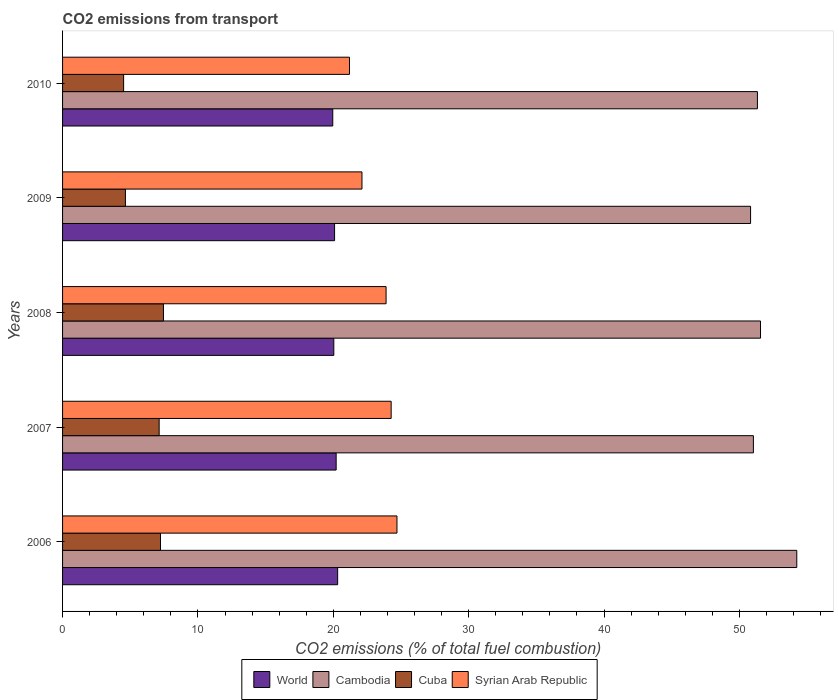How many different coloured bars are there?
Make the answer very short. 4. How many groups of bars are there?
Make the answer very short. 5. Are the number of bars on each tick of the Y-axis equal?
Give a very brief answer. Yes. What is the total CO2 emitted in Syrian Arab Republic in 2010?
Your response must be concise. 21.2. Across all years, what is the maximum total CO2 emitted in Cuba?
Ensure brevity in your answer.  7.45. Across all years, what is the minimum total CO2 emitted in Syrian Arab Republic?
Your answer should be compact. 21.2. In which year was the total CO2 emitted in World maximum?
Keep it short and to the point. 2006. In which year was the total CO2 emitted in Cambodia minimum?
Provide a succinct answer. 2009. What is the total total CO2 emitted in Cambodia in the graph?
Give a very brief answer. 258.98. What is the difference between the total CO2 emitted in Cambodia in 2008 and that in 2010?
Ensure brevity in your answer.  0.23. What is the difference between the total CO2 emitted in Cambodia in 2009 and the total CO2 emitted in Syrian Arab Republic in 2007?
Your answer should be very brief. 26.55. What is the average total CO2 emitted in Syrian Arab Republic per year?
Offer a very short reply. 23.24. In the year 2009, what is the difference between the total CO2 emitted in World and total CO2 emitted in Syrian Arab Republic?
Offer a terse response. -2.02. In how many years, is the total CO2 emitted in Cuba greater than 52 ?
Ensure brevity in your answer.  0. What is the ratio of the total CO2 emitted in Syrian Arab Republic in 2006 to that in 2008?
Make the answer very short. 1.03. What is the difference between the highest and the second highest total CO2 emitted in Cambodia?
Your answer should be very brief. 2.68. What is the difference between the highest and the lowest total CO2 emitted in World?
Keep it short and to the point. 0.36. Is the sum of the total CO2 emitted in Syrian Arab Republic in 2008 and 2010 greater than the maximum total CO2 emitted in World across all years?
Ensure brevity in your answer.  Yes. What does the 2nd bar from the top in 2007 represents?
Provide a short and direct response. Cuba. Is it the case that in every year, the sum of the total CO2 emitted in Cuba and total CO2 emitted in World is greater than the total CO2 emitted in Syrian Arab Republic?
Keep it short and to the point. Yes. How many bars are there?
Make the answer very short. 20. How many years are there in the graph?
Provide a succinct answer. 5. What is the difference between two consecutive major ticks on the X-axis?
Your answer should be very brief. 10. How many legend labels are there?
Make the answer very short. 4. What is the title of the graph?
Your response must be concise. CO2 emissions from transport. What is the label or title of the X-axis?
Give a very brief answer. CO2 emissions (% of total fuel combustion). What is the CO2 emissions (% of total fuel combustion) in World in 2006?
Keep it short and to the point. 20.32. What is the CO2 emissions (% of total fuel combustion) of Cambodia in 2006?
Keep it short and to the point. 54.24. What is the CO2 emissions (% of total fuel combustion) in Cuba in 2006?
Provide a short and direct response. 7.23. What is the CO2 emissions (% of total fuel combustion) of Syrian Arab Republic in 2006?
Your answer should be very brief. 24.7. What is the CO2 emissions (% of total fuel combustion) in World in 2007?
Ensure brevity in your answer.  20.21. What is the CO2 emissions (% of total fuel combustion) in Cambodia in 2007?
Your answer should be very brief. 51.03. What is the CO2 emissions (% of total fuel combustion) of Cuba in 2007?
Your answer should be very brief. 7.13. What is the CO2 emissions (% of total fuel combustion) of Syrian Arab Republic in 2007?
Provide a succinct answer. 24.27. What is the CO2 emissions (% of total fuel combustion) of World in 2008?
Provide a short and direct response. 20.04. What is the CO2 emissions (% of total fuel combustion) of Cambodia in 2008?
Provide a succinct answer. 51.56. What is the CO2 emissions (% of total fuel combustion) in Cuba in 2008?
Your response must be concise. 7.45. What is the CO2 emissions (% of total fuel combustion) of Syrian Arab Republic in 2008?
Your answer should be compact. 23.9. What is the CO2 emissions (% of total fuel combustion) in World in 2009?
Provide a succinct answer. 20.09. What is the CO2 emissions (% of total fuel combustion) in Cambodia in 2009?
Your response must be concise. 50.82. What is the CO2 emissions (% of total fuel combustion) of Cuba in 2009?
Your answer should be very brief. 4.64. What is the CO2 emissions (% of total fuel combustion) of Syrian Arab Republic in 2009?
Your response must be concise. 22.12. What is the CO2 emissions (% of total fuel combustion) in World in 2010?
Give a very brief answer. 19.96. What is the CO2 emissions (% of total fuel combustion) of Cambodia in 2010?
Offer a very short reply. 51.33. What is the CO2 emissions (% of total fuel combustion) in Cuba in 2010?
Your answer should be very brief. 4.51. What is the CO2 emissions (% of total fuel combustion) of Syrian Arab Republic in 2010?
Offer a very short reply. 21.2. Across all years, what is the maximum CO2 emissions (% of total fuel combustion) of World?
Your answer should be very brief. 20.32. Across all years, what is the maximum CO2 emissions (% of total fuel combustion) of Cambodia?
Provide a succinct answer. 54.24. Across all years, what is the maximum CO2 emissions (% of total fuel combustion) of Cuba?
Offer a very short reply. 7.45. Across all years, what is the maximum CO2 emissions (% of total fuel combustion) of Syrian Arab Republic?
Ensure brevity in your answer.  24.7. Across all years, what is the minimum CO2 emissions (% of total fuel combustion) in World?
Make the answer very short. 19.96. Across all years, what is the minimum CO2 emissions (% of total fuel combustion) of Cambodia?
Ensure brevity in your answer.  50.82. Across all years, what is the minimum CO2 emissions (% of total fuel combustion) of Cuba?
Offer a very short reply. 4.51. Across all years, what is the minimum CO2 emissions (% of total fuel combustion) in Syrian Arab Republic?
Offer a very short reply. 21.2. What is the total CO2 emissions (% of total fuel combustion) in World in the graph?
Give a very brief answer. 100.62. What is the total CO2 emissions (% of total fuel combustion) in Cambodia in the graph?
Your response must be concise. 258.98. What is the total CO2 emissions (% of total fuel combustion) in Cuba in the graph?
Offer a terse response. 30.98. What is the total CO2 emissions (% of total fuel combustion) in Syrian Arab Republic in the graph?
Offer a very short reply. 116.19. What is the difference between the CO2 emissions (% of total fuel combustion) of World in 2006 and that in 2007?
Your response must be concise. 0.11. What is the difference between the CO2 emissions (% of total fuel combustion) in Cambodia in 2006 and that in 2007?
Make the answer very short. 3.2. What is the difference between the CO2 emissions (% of total fuel combustion) in Cuba in 2006 and that in 2007?
Provide a succinct answer. 0.1. What is the difference between the CO2 emissions (% of total fuel combustion) of Syrian Arab Republic in 2006 and that in 2007?
Keep it short and to the point. 0.43. What is the difference between the CO2 emissions (% of total fuel combustion) of World in 2006 and that in 2008?
Your answer should be very brief. 0.28. What is the difference between the CO2 emissions (% of total fuel combustion) of Cambodia in 2006 and that in 2008?
Your response must be concise. 2.68. What is the difference between the CO2 emissions (% of total fuel combustion) in Cuba in 2006 and that in 2008?
Provide a short and direct response. -0.22. What is the difference between the CO2 emissions (% of total fuel combustion) of Syrian Arab Republic in 2006 and that in 2008?
Ensure brevity in your answer.  0.8. What is the difference between the CO2 emissions (% of total fuel combustion) of World in 2006 and that in 2009?
Your answer should be very brief. 0.23. What is the difference between the CO2 emissions (% of total fuel combustion) of Cambodia in 2006 and that in 2009?
Give a very brief answer. 3.41. What is the difference between the CO2 emissions (% of total fuel combustion) of Cuba in 2006 and that in 2009?
Keep it short and to the point. 2.59. What is the difference between the CO2 emissions (% of total fuel combustion) of Syrian Arab Republic in 2006 and that in 2009?
Make the answer very short. 2.58. What is the difference between the CO2 emissions (% of total fuel combustion) of World in 2006 and that in 2010?
Provide a succinct answer. 0.36. What is the difference between the CO2 emissions (% of total fuel combustion) of Cambodia in 2006 and that in 2010?
Ensure brevity in your answer.  2.91. What is the difference between the CO2 emissions (% of total fuel combustion) in Cuba in 2006 and that in 2010?
Keep it short and to the point. 2.72. What is the difference between the CO2 emissions (% of total fuel combustion) in Syrian Arab Republic in 2006 and that in 2010?
Offer a very short reply. 3.51. What is the difference between the CO2 emissions (% of total fuel combustion) in World in 2007 and that in 2008?
Your answer should be compact. 0.17. What is the difference between the CO2 emissions (% of total fuel combustion) in Cambodia in 2007 and that in 2008?
Provide a short and direct response. -0.53. What is the difference between the CO2 emissions (% of total fuel combustion) in Cuba in 2007 and that in 2008?
Offer a terse response. -0.32. What is the difference between the CO2 emissions (% of total fuel combustion) of Syrian Arab Republic in 2007 and that in 2008?
Provide a succinct answer. 0.38. What is the difference between the CO2 emissions (% of total fuel combustion) in World in 2007 and that in 2009?
Provide a succinct answer. 0.12. What is the difference between the CO2 emissions (% of total fuel combustion) of Cambodia in 2007 and that in 2009?
Offer a terse response. 0.21. What is the difference between the CO2 emissions (% of total fuel combustion) of Cuba in 2007 and that in 2009?
Offer a very short reply. 2.49. What is the difference between the CO2 emissions (% of total fuel combustion) of Syrian Arab Republic in 2007 and that in 2009?
Provide a succinct answer. 2.16. What is the difference between the CO2 emissions (% of total fuel combustion) in World in 2007 and that in 2010?
Offer a very short reply. 0.25. What is the difference between the CO2 emissions (% of total fuel combustion) in Cambodia in 2007 and that in 2010?
Your response must be concise. -0.3. What is the difference between the CO2 emissions (% of total fuel combustion) in Cuba in 2007 and that in 2010?
Make the answer very short. 2.62. What is the difference between the CO2 emissions (% of total fuel combustion) in Syrian Arab Republic in 2007 and that in 2010?
Ensure brevity in your answer.  3.08. What is the difference between the CO2 emissions (% of total fuel combustion) in World in 2008 and that in 2009?
Keep it short and to the point. -0.06. What is the difference between the CO2 emissions (% of total fuel combustion) of Cambodia in 2008 and that in 2009?
Give a very brief answer. 0.73. What is the difference between the CO2 emissions (% of total fuel combustion) of Cuba in 2008 and that in 2009?
Keep it short and to the point. 2.81. What is the difference between the CO2 emissions (% of total fuel combustion) in Syrian Arab Republic in 2008 and that in 2009?
Your response must be concise. 1.78. What is the difference between the CO2 emissions (% of total fuel combustion) of World in 2008 and that in 2010?
Make the answer very short. 0.08. What is the difference between the CO2 emissions (% of total fuel combustion) in Cambodia in 2008 and that in 2010?
Your answer should be compact. 0.23. What is the difference between the CO2 emissions (% of total fuel combustion) in Cuba in 2008 and that in 2010?
Provide a succinct answer. 2.94. What is the difference between the CO2 emissions (% of total fuel combustion) of Syrian Arab Republic in 2008 and that in 2010?
Offer a terse response. 2.7. What is the difference between the CO2 emissions (% of total fuel combustion) of World in 2009 and that in 2010?
Offer a terse response. 0.13. What is the difference between the CO2 emissions (% of total fuel combustion) of Cambodia in 2009 and that in 2010?
Your answer should be very brief. -0.51. What is the difference between the CO2 emissions (% of total fuel combustion) in Cuba in 2009 and that in 2010?
Provide a succinct answer. 0.13. What is the difference between the CO2 emissions (% of total fuel combustion) in Syrian Arab Republic in 2009 and that in 2010?
Offer a very short reply. 0.92. What is the difference between the CO2 emissions (% of total fuel combustion) of World in 2006 and the CO2 emissions (% of total fuel combustion) of Cambodia in 2007?
Keep it short and to the point. -30.71. What is the difference between the CO2 emissions (% of total fuel combustion) in World in 2006 and the CO2 emissions (% of total fuel combustion) in Cuba in 2007?
Offer a very short reply. 13.19. What is the difference between the CO2 emissions (% of total fuel combustion) of World in 2006 and the CO2 emissions (% of total fuel combustion) of Syrian Arab Republic in 2007?
Your answer should be very brief. -3.95. What is the difference between the CO2 emissions (% of total fuel combustion) of Cambodia in 2006 and the CO2 emissions (% of total fuel combustion) of Cuba in 2007?
Provide a succinct answer. 47.1. What is the difference between the CO2 emissions (% of total fuel combustion) in Cambodia in 2006 and the CO2 emissions (% of total fuel combustion) in Syrian Arab Republic in 2007?
Provide a succinct answer. 29.96. What is the difference between the CO2 emissions (% of total fuel combustion) in Cuba in 2006 and the CO2 emissions (% of total fuel combustion) in Syrian Arab Republic in 2007?
Your response must be concise. -17.04. What is the difference between the CO2 emissions (% of total fuel combustion) in World in 2006 and the CO2 emissions (% of total fuel combustion) in Cambodia in 2008?
Keep it short and to the point. -31.24. What is the difference between the CO2 emissions (% of total fuel combustion) in World in 2006 and the CO2 emissions (% of total fuel combustion) in Cuba in 2008?
Ensure brevity in your answer.  12.87. What is the difference between the CO2 emissions (% of total fuel combustion) in World in 2006 and the CO2 emissions (% of total fuel combustion) in Syrian Arab Republic in 2008?
Provide a succinct answer. -3.58. What is the difference between the CO2 emissions (% of total fuel combustion) in Cambodia in 2006 and the CO2 emissions (% of total fuel combustion) in Cuba in 2008?
Your answer should be compact. 46.78. What is the difference between the CO2 emissions (% of total fuel combustion) of Cambodia in 2006 and the CO2 emissions (% of total fuel combustion) of Syrian Arab Republic in 2008?
Ensure brevity in your answer.  30.34. What is the difference between the CO2 emissions (% of total fuel combustion) of Cuba in 2006 and the CO2 emissions (% of total fuel combustion) of Syrian Arab Republic in 2008?
Make the answer very short. -16.66. What is the difference between the CO2 emissions (% of total fuel combustion) in World in 2006 and the CO2 emissions (% of total fuel combustion) in Cambodia in 2009?
Give a very brief answer. -30.5. What is the difference between the CO2 emissions (% of total fuel combustion) in World in 2006 and the CO2 emissions (% of total fuel combustion) in Cuba in 2009?
Provide a short and direct response. 15.68. What is the difference between the CO2 emissions (% of total fuel combustion) of World in 2006 and the CO2 emissions (% of total fuel combustion) of Syrian Arab Republic in 2009?
Offer a very short reply. -1.8. What is the difference between the CO2 emissions (% of total fuel combustion) of Cambodia in 2006 and the CO2 emissions (% of total fuel combustion) of Cuba in 2009?
Provide a short and direct response. 49.59. What is the difference between the CO2 emissions (% of total fuel combustion) in Cambodia in 2006 and the CO2 emissions (% of total fuel combustion) in Syrian Arab Republic in 2009?
Keep it short and to the point. 32.12. What is the difference between the CO2 emissions (% of total fuel combustion) of Cuba in 2006 and the CO2 emissions (% of total fuel combustion) of Syrian Arab Republic in 2009?
Your answer should be compact. -14.88. What is the difference between the CO2 emissions (% of total fuel combustion) of World in 2006 and the CO2 emissions (% of total fuel combustion) of Cambodia in 2010?
Offer a terse response. -31.01. What is the difference between the CO2 emissions (% of total fuel combustion) in World in 2006 and the CO2 emissions (% of total fuel combustion) in Cuba in 2010?
Your response must be concise. 15.81. What is the difference between the CO2 emissions (% of total fuel combustion) in World in 2006 and the CO2 emissions (% of total fuel combustion) in Syrian Arab Republic in 2010?
Offer a very short reply. -0.88. What is the difference between the CO2 emissions (% of total fuel combustion) in Cambodia in 2006 and the CO2 emissions (% of total fuel combustion) in Cuba in 2010?
Provide a succinct answer. 49.73. What is the difference between the CO2 emissions (% of total fuel combustion) of Cambodia in 2006 and the CO2 emissions (% of total fuel combustion) of Syrian Arab Republic in 2010?
Make the answer very short. 33.04. What is the difference between the CO2 emissions (% of total fuel combustion) of Cuba in 2006 and the CO2 emissions (% of total fuel combustion) of Syrian Arab Republic in 2010?
Make the answer very short. -13.96. What is the difference between the CO2 emissions (% of total fuel combustion) in World in 2007 and the CO2 emissions (% of total fuel combustion) in Cambodia in 2008?
Ensure brevity in your answer.  -31.35. What is the difference between the CO2 emissions (% of total fuel combustion) in World in 2007 and the CO2 emissions (% of total fuel combustion) in Cuba in 2008?
Your answer should be compact. 12.76. What is the difference between the CO2 emissions (% of total fuel combustion) in World in 2007 and the CO2 emissions (% of total fuel combustion) in Syrian Arab Republic in 2008?
Your answer should be very brief. -3.69. What is the difference between the CO2 emissions (% of total fuel combustion) in Cambodia in 2007 and the CO2 emissions (% of total fuel combustion) in Cuba in 2008?
Keep it short and to the point. 43.58. What is the difference between the CO2 emissions (% of total fuel combustion) in Cambodia in 2007 and the CO2 emissions (% of total fuel combustion) in Syrian Arab Republic in 2008?
Offer a very short reply. 27.13. What is the difference between the CO2 emissions (% of total fuel combustion) of Cuba in 2007 and the CO2 emissions (% of total fuel combustion) of Syrian Arab Republic in 2008?
Your response must be concise. -16.76. What is the difference between the CO2 emissions (% of total fuel combustion) of World in 2007 and the CO2 emissions (% of total fuel combustion) of Cambodia in 2009?
Your answer should be compact. -30.61. What is the difference between the CO2 emissions (% of total fuel combustion) of World in 2007 and the CO2 emissions (% of total fuel combustion) of Cuba in 2009?
Your response must be concise. 15.57. What is the difference between the CO2 emissions (% of total fuel combustion) of World in 2007 and the CO2 emissions (% of total fuel combustion) of Syrian Arab Republic in 2009?
Keep it short and to the point. -1.91. What is the difference between the CO2 emissions (% of total fuel combustion) of Cambodia in 2007 and the CO2 emissions (% of total fuel combustion) of Cuba in 2009?
Give a very brief answer. 46.39. What is the difference between the CO2 emissions (% of total fuel combustion) in Cambodia in 2007 and the CO2 emissions (% of total fuel combustion) in Syrian Arab Republic in 2009?
Make the answer very short. 28.91. What is the difference between the CO2 emissions (% of total fuel combustion) in Cuba in 2007 and the CO2 emissions (% of total fuel combustion) in Syrian Arab Republic in 2009?
Keep it short and to the point. -14.98. What is the difference between the CO2 emissions (% of total fuel combustion) in World in 2007 and the CO2 emissions (% of total fuel combustion) in Cambodia in 2010?
Offer a terse response. -31.12. What is the difference between the CO2 emissions (% of total fuel combustion) of World in 2007 and the CO2 emissions (% of total fuel combustion) of Cuba in 2010?
Provide a succinct answer. 15.7. What is the difference between the CO2 emissions (% of total fuel combustion) in World in 2007 and the CO2 emissions (% of total fuel combustion) in Syrian Arab Republic in 2010?
Keep it short and to the point. -0.99. What is the difference between the CO2 emissions (% of total fuel combustion) of Cambodia in 2007 and the CO2 emissions (% of total fuel combustion) of Cuba in 2010?
Your answer should be very brief. 46.52. What is the difference between the CO2 emissions (% of total fuel combustion) of Cambodia in 2007 and the CO2 emissions (% of total fuel combustion) of Syrian Arab Republic in 2010?
Your response must be concise. 29.84. What is the difference between the CO2 emissions (% of total fuel combustion) of Cuba in 2007 and the CO2 emissions (% of total fuel combustion) of Syrian Arab Republic in 2010?
Give a very brief answer. -14.06. What is the difference between the CO2 emissions (% of total fuel combustion) in World in 2008 and the CO2 emissions (% of total fuel combustion) in Cambodia in 2009?
Provide a short and direct response. -30.79. What is the difference between the CO2 emissions (% of total fuel combustion) in World in 2008 and the CO2 emissions (% of total fuel combustion) in Cuba in 2009?
Offer a very short reply. 15.39. What is the difference between the CO2 emissions (% of total fuel combustion) in World in 2008 and the CO2 emissions (% of total fuel combustion) in Syrian Arab Republic in 2009?
Make the answer very short. -2.08. What is the difference between the CO2 emissions (% of total fuel combustion) in Cambodia in 2008 and the CO2 emissions (% of total fuel combustion) in Cuba in 2009?
Keep it short and to the point. 46.91. What is the difference between the CO2 emissions (% of total fuel combustion) of Cambodia in 2008 and the CO2 emissions (% of total fuel combustion) of Syrian Arab Republic in 2009?
Keep it short and to the point. 29.44. What is the difference between the CO2 emissions (% of total fuel combustion) in Cuba in 2008 and the CO2 emissions (% of total fuel combustion) in Syrian Arab Republic in 2009?
Provide a short and direct response. -14.66. What is the difference between the CO2 emissions (% of total fuel combustion) in World in 2008 and the CO2 emissions (% of total fuel combustion) in Cambodia in 2010?
Your answer should be compact. -31.29. What is the difference between the CO2 emissions (% of total fuel combustion) of World in 2008 and the CO2 emissions (% of total fuel combustion) of Cuba in 2010?
Ensure brevity in your answer.  15.53. What is the difference between the CO2 emissions (% of total fuel combustion) of World in 2008 and the CO2 emissions (% of total fuel combustion) of Syrian Arab Republic in 2010?
Offer a very short reply. -1.16. What is the difference between the CO2 emissions (% of total fuel combustion) in Cambodia in 2008 and the CO2 emissions (% of total fuel combustion) in Cuba in 2010?
Your answer should be very brief. 47.05. What is the difference between the CO2 emissions (% of total fuel combustion) of Cambodia in 2008 and the CO2 emissions (% of total fuel combustion) of Syrian Arab Republic in 2010?
Your answer should be very brief. 30.36. What is the difference between the CO2 emissions (% of total fuel combustion) of Cuba in 2008 and the CO2 emissions (% of total fuel combustion) of Syrian Arab Republic in 2010?
Provide a succinct answer. -13.74. What is the difference between the CO2 emissions (% of total fuel combustion) in World in 2009 and the CO2 emissions (% of total fuel combustion) in Cambodia in 2010?
Provide a succinct answer. -31.24. What is the difference between the CO2 emissions (% of total fuel combustion) in World in 2009 and the CO2 emissions (% of total fuel combustion) in Cuba in 2010?
Provide a short and direct response. 15.58. What is the difference between the CO2 emissions (% of total fuel combustion) in World in 2009 and the CO2 emissions (% of total fuel combustion) in Syrian Arab Republic in 2010?
Ensure brevity in your answer.  -1.1. What is the difference between the CO2 emissions (% of total fuel combustion) of Cambodia in 2009 and the CO2 emissions (% of total fuel combustion) of Cuba in 2010?
Provide a succinct answer. 46.31. What is the difference between the CO2 emissions (% of total fuel combustion) of Cambodia in 2009 and the CO2 emissions (% of total fuel combustion) of Syrian Arab Republic in 2010?
Offer a terse response. 29.63. What is the difference between the CO2 emissions (% of total fuel combustion) in Cuba in 2009 and the CO2 emissions (% of total fuel combustion) in Syrian Arab Republic in 2010?
Keep it short and to the point. -16.55. What is the average CO2 emissions (% of total fuel combustion) of World per year?
Provide a succinct answer. 20.12. What is the average CO2 emissions (% of total fuel combustion) of Cambodia per year?
Provide a short and direct response. 51.8. What is the average CO2 emissions (% of total fuel combustion) of Cuba per year?
Your answer should be very brief. 6.2. What is the average CO2 emissions (% of total fuel combustion) of Syrian Arab Republic per year?
Provide a short and direct response. 23.24. In the year 2006, what is the difference between the CO2 emissions (% of total fuel combustion) in World and CO2 emissions (% of total fuel combustion) in Cambodia?
Your answer should be very brief. -33.92. In the year 2006, what is the difference between the CO2 emissions (% of total fuel combustion) of World and CO2 emissions (% of total fuel combustion) of Cuba?
Ensure brevity in your answer.  13.09. In the year 2006, what is the difference between the CO2 emissions (% of total fuel combustion) in World and CO2 emissions (% of total fuel combustion) in Syrian Arab Republic?
Provide a succinct answer. -4.38. In the year 2006, what is the difference between the CO2 emissions (% of total fuel combustion) in Cambodia and CO2 emissions (% of total fuel combustion) in Cuba?
Offer a very short reply. 47. In the year 2006, what is the difference between the CO2 emissions (% of total fuel combustion) in Cambodia and CO2 emissions (% of total fuel combustion) in Syrian Arab Republic?
Keep it short and to the point. 29.53. In the year 2006, what is the difference between the CO2 emissions (% of total fuel combustion) in Cuba and CO2 emissions (% of total fuel combustion) in Syrian Arab Republic?
Keep it short and to the point. -17.47. In the year 2007, what is the difference between the CO2 emissions (% of total fuel combustion) in World and CO2 emissions (% of total fuel combustion) in Cambodia?
Your response must be concise. -30.82. In the year 2007, what is the difference between the CO2 emissions (% of total fuel combustion) of World and CO2 emissions (% of total fuel combustion) of Cuba?
Offer a very short reply. 13.08. In the year 2007, what is the difference between the CO2 emissions (% of total fuel combustion) of World and CO2 emissions (% of total fuel combustion) of Syrian Arab Republic?
Provide a succinct answer. -4.06. In the year 2007, what is the difference between the CO2 emissions (% of total fuel combustion) of Cambodia and CO2 emissions (% of total fuel combustion) of Cuba?
Your response must be concise. 43.9. In the year 2007, what is the difference between the CO2 emissions (% of total fuel combustion) of Cambodia and CO2 emissions (% of total fuel combustion) of Syrian Arab Republic?
Provide a succinct answer. 26.76. In the year 2007, what is the difference between the CO2 emissions (% of total fuel combustion) in Cuba and CO2 emissions (% of total fuel combustion) in Syrian Arab Republic?
Keep it short and to the point. -17.14. In the year 2008, what is the difference between the CO2 emissions (% of total fuel combustion) in World and CO2 emissions (% of total fuel combustion) in Cambodia?
Keep it short and to the point. -31.52. In the year 2008, what is the difference between the CO2 emissions (% of total fuel combustion) in World and CO2 emissions (% of total fuel combustion) in Cuba?
Keep it short and to the point. 12.58. In the year 2008, what is the difference between the CO2 emissions (% of total fuel combustion) of World and CO2 emissions (% of total fuel combustion) of Syrian Arab Republic?
Your answer should be compact. -3.86. In the year 2008, what is the difference between the CO2 emissions (% of total fuel combustion) of Cambodia and CO2 emissions (% of total fuel combustion) of Cuba?
Offer a terse response. 44.1. In the year 2008, what is the difference between the CO2 emissions (% of total fuel combustion) of Cambodia and CO2 emissions (% of total fuel combustion) of Syrian Arab Republic?
Give a very brief answer. 27.66. In the year 2008, what is the difference between the CO2 emissions (% of total fuel combustion) in Cuba and CO2 emissions (% of total fuel combustion) in Syrian Arab Republic?
Ensure brevity in your answer.  -16.45. In the year 2009, what is the difference between the CO2 emissions (% of total fuel combustion) in World and CO2 emissions (% of total fuel combustion) in Cambodia?
Make the answer very short. -30.73. In the year 2009, what is the difference between the CO2 emissions (% of total fuel combustion) of World and CO2 emissions (% of total fuel combustion) of Cuba?
Give a very brief answer. 15.45. In the year 2009, what is the difference between the CO2 emissions (% of total fuel combustion) in World and CO2 emissions (% of total fuel combustion) in Syrian Arab Republic?
Keep it short and to the point. -2.02. In the year 2009, what is the difference between the CO2 emissions (% of total fuel combustion) of Cambodia and CO2 emissions (% of total fuel combustion) of Cuba?
Provide a succinct answer. 46.18. In the year 2009, what is the difference between the CO2 emissions (% of total fuel combustion) of Cambodia and CO2 emissions (% of total fuel combustion) of Syrian Arab Republic?
Offer a very short reply. 28.71. In the year 2009, what is the difference between the CO2 emissions (% of total fuel combustion) of Cuba and CO2 emissions (% of total fuel combustion) of Syrian Arab Republic?
Provide a succinct answer. -17.47. In the year 2010, what is the difference between the CO2 emissions (% of total fuel combustion) of World and CO2 emissions (% of total fuel combustion) of Cambodia?
Offer a terse response. -31.37. In the year 2010, what is the difference between the CO2 emissions (% of total fuel combustion) of World and CO2 emissions (% of total fuel combustion) of Cuba?
Your response must be concise. 15.45. In the year 2010, what is the difference between the CO2 emissions (% of total fuel combustion) in World and CO2 emissions (% of total fuel combustion) in Syrian Arab Republic?
Provide a short and direct response. -1.24. In the year 2010, what is the difference between the CO2 emissions (% of total fuel combustion) in Cambodia and CO2 emissions (% of total fuel combustion) in Cuba?
Make the answer very short. 46.82. In the year 2010, what is the difference between the CO2 emissions (% of total fuel combustion) of Cambodia and CO2 emissions (% of total fuel combustion) of Syrian Arab Republic?
Keep it short and to the point. 30.13. In the year 2010, what is the difference between the CO2 emissions (% of total fuel combustion) of Cuba and CO2 emissions (% of total fuel combustion) of Syrian Arab Republic?
Ensure brevity in your answer.  -16.69. What is the ratio of the CO2 emissions (% of total fuel combustion) in Cambodia in 2006 to that in 2007?
Keep it short and to the point. 1.06. What is the ratio of the CO2 emissions (% of total fuel combustion) in Cuba in 2006 to that in 2007?
Ensure brevity in your answer.  1.01. What is the ratio of the CO2 emissions (% of total fuel combustion) of Syrian Arab Republic in 2006 to that in 2007?
Offer a terse response. 1.02. What is the ratio of the CO2 emissions (% of total fuel combustion) in World in 2006 to that in 2008?
Provide a short and direct response. 1.01. What is the ratio of the CO2 emissions (% of total fuel combustion) of Cambodia in 2006 to that in 2008?
Keep it short and to the point. 1.05. What is the ratio of the CO2 emissions (% of total fuel combustion) in Cuba in 2006 to that in 2008?
Offer a terse response. 0.97. What is the ratio of the CO2 emissions (% of total fuel combustion) in Syrian Arab Republic in 2006 to that in 2008?
Make the answer very short. 1.03. What is the ratio of the CO2 emissions (% of total fuel combustion) of World in 2006 to that in 2009?
Offer a very short reply. 1.01. What is the ratio of the CO2 emissions (% of total fuel combustion) in Cambodia in 2006 to that in 2009?
Give a very brief answer. 1.07. What is the ratio of the CO2 emissions (% of total fuel combustion) of Cuba in 2006 to that in 2009?
Ensure brevity in your answer.  1.56. What is the ratio of the CO2 emissions (% of total fuel combustion) of Syrian Arab Republic in 2006 to that in 2009?
Provide a short and direct response. 1.12. What is the ratio of the CO2 emissions (% of total fuel combustion) in World in 2006 to that in 2010?
Your answer should be very brief. 1.02. What is the ratio of the CO2 emissions (% of total fuel combustion) in Cambodia in 2006 to that in 2010?
Offer a terse response. 1.06. What is the ratio of the CO2 emissions (% of total fuel combustion) in Cuba in 2006 to that in 2010?
Offer a terse response. 1.6. What is the ratio of the CO2 emissions (% of total fuel combustion) in Syrian Arab Republic in 2006 to that in 2010?
Your response must be concise. 1.17. What is the ratio of the CO2 emissions (% of total fuel combustion) of World in 2007 to that in 2008?
Provide a short and direct response. 1.01. What is the ratio of the CO2 emissions (% of total fuel combustion) in Cambodia in 2007 to that in 2008?
Offer a very short reply. 0.99. What is the ratio of the CO2 emissions (% of total fuel combustion) of Cuba in 2007 to that in 2008?
Offer a terse response. 0.96. What is the ratio of the CO2 emissions (% of total fuel combustion) of Syrian Arab Republic in 2007 to that in 2008?
Give a very brief answer. 1.02. What is the ratio of the CO2 emissions (% of total fuel combustion) in Cambodia in 2007 to that in 2009?
Your answer should be very brief. 1. What is the ratio of the CO2 emissions (% of total fuel combustion) in Cuba in 2007 to that in 2009?
Keep it short and to the point. 1.54. What is the ratio of the CO2 emissions (% of total fuel combustion) in Syrian Arab Republic in 2007 to that in 2009?
Offer a terse response. 1.1. What is the ratio of the CO2 emissions (% of total fuel combustion) in World in 2007 to that in 2010?
Provide a succinct answer. 1.01. What is the ratio of the CO2 emissions (% of total fuel combustion) of Cuba in 2007 to that in 2010?
Offer a very short reply. 1.58. What is the ratio of the CO2 emissions (% of total fuel combustion) of Syrian Arab Republic in 2007 to that in 2010?
Your answer should be compact. 1.15. What is the ratio of the CO2 emissions (% of total fuel combustion) of World in 2008 to that in 2009?
Make the answer very short. 1. What is the ratio of the CO2 emissions (% of total fuel combustion) of Cambodia in 2008 to that in 2009?
Provide a short and direct response. 1.01. What is the ratio of the CO2 emissions (% of total fuel combustion) in Cuba in 2008 to that in 2009?
Your answer should be compact. 1.61. What is the ratio of the CO2 emissions (% of total fuel combustion) of Syrian Arab Republic in 2008 to that in 2009?
Offer a very short reply. 1.08. What is the ratio of the CO2 emissions (% of total fuel combustion) of World in 2008 to that in 2010?
Provide a short and direct response. 1. What is the ratio of the CO2 emissions (% of total fuel combustion) in Cuba in 2008 to that in 2010?
Provide a short and direct response. 1.65. What is the ratio of the CO2 emissions (% of total fuel combustion) of Syrian Arab Republic in 2008 to that in 2010?
Provide a succinct answer. 1.13. What is the ratio of the CO2 emissions (% of total fuel combustion) in World in 2009 to that in 2010?
Provide a short and direct response. 1.01. What is the ratio of the CO2 emissions (% of total fuel combustion) in Cambodia in 2009 to that in 2010?
Provide a short and direct response. 0.99. What is the ratio of the CO2 emissions (% of total fuel combustion) in Cuba in 2009 to that in 2010?
Make the answer very short. 1.03. What is the ratio of the CO2 emissions (% of total fuel combustion) of Syrian Arab Republic in 2009 to that in 2010?
Offer a very short reply. 1.04. What is the difference between the highest and the second highest CO2 emissions (% of total fuel combustion) of World?
Give a very brief answer. 0.11. What is the difference between the highest and the second highest CO2 emissions (% of total fuel combustion) of Cambodia?
Give a very brief answer. 2.68. What is the difference between the highest and the second highest CO2 emissions (% of total fuel combustion) in Cuba?
Your answer should be very brief. 0.22. What is the difference between the highest and the second highest CO2 emissions (% of total fuel combustion) of Syrian Arab Republic?
Make the answer very short. 0.43. What is the difference between the highest and the lowest CO2 emissions (% of total fuel combustion) of World?
Your response must be concise. 0.36. What is the difference between the highest and the lowest CO2 emissions (% of total fuel combustion) of Cambodia?
Provide a succinct answer. 3.41. What is the difference between the highest and the lowest CO2 emissions (% of total fuel combustion) of Cuba?
Your response must be concise. 2.94. What is the difference between the highest and the lowest CO2 emissions (% of total fuel combustion) of Syrian Arab Republic?
Offer a terse response. 3.51. 